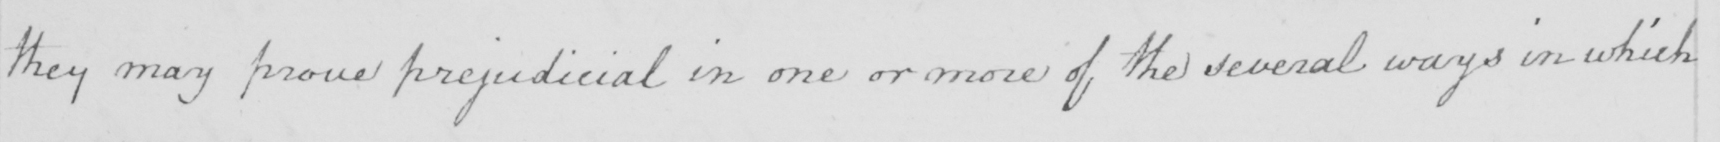Transcribe the text shown in this historical manuscript line. they may prove prejudicial in one or more of the several ways in which 